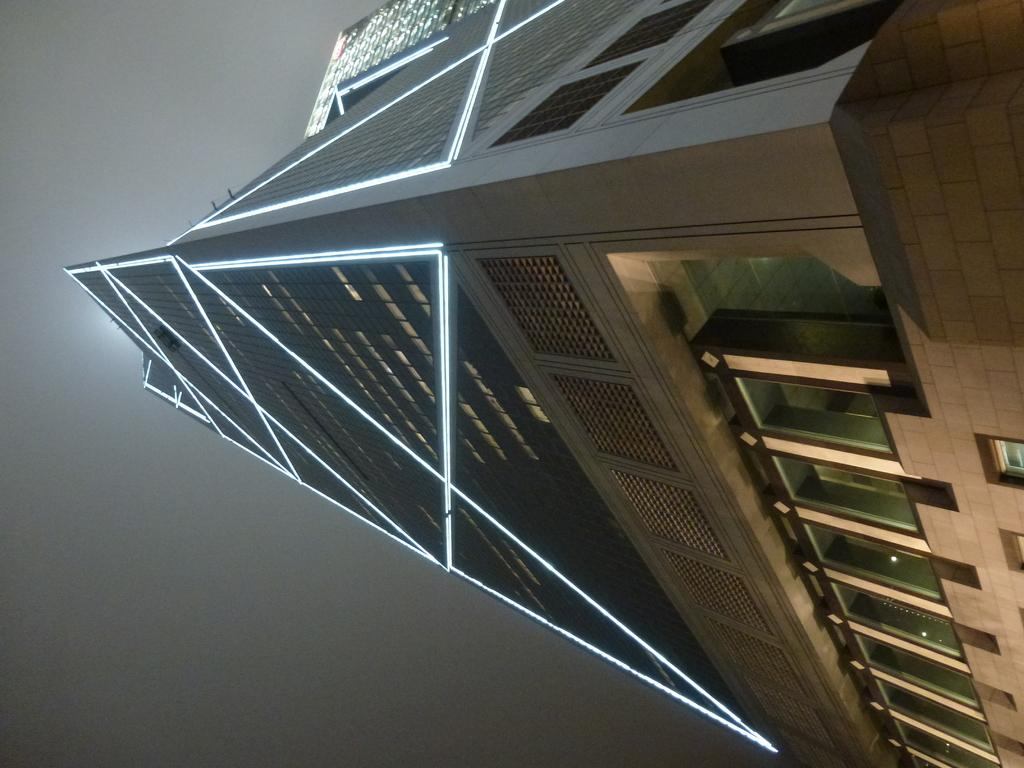What is the main subject in the foreground of the image? There is a building in the foreground of the image. What feature can be seen on the building? The building has windows. What can be seen in the background of the image? The sky is visible in the background of the image. What time of day was the image taken? The image was taken during nighttime. What shape is the hammer in the image? There is no hammer present in the image. What type of land can be seen in the image? The image does not show any land; it features a building and the sky. 